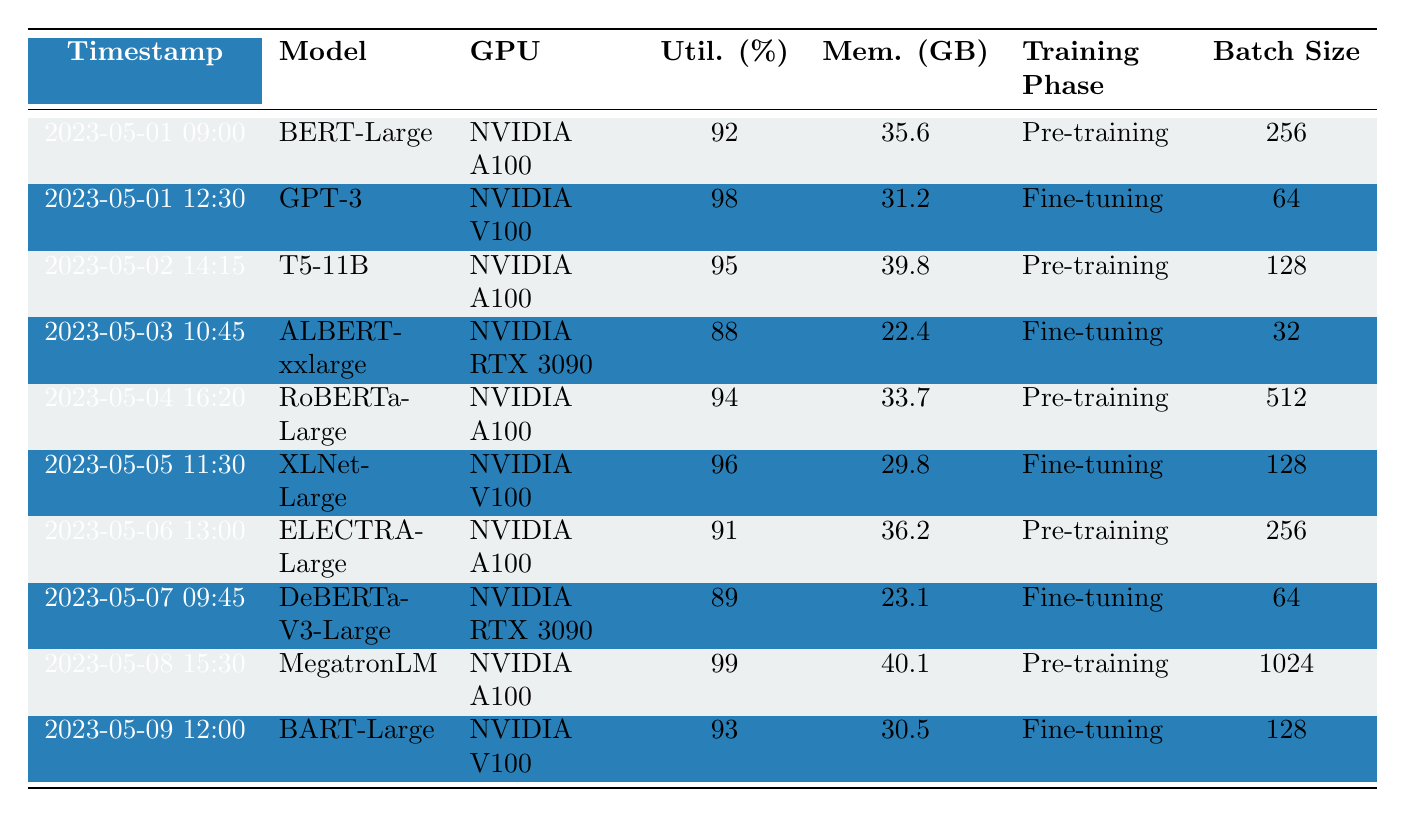What is the highest GPU utilization recorded in the table? Looking through the "Utilization (%)" column, the highest value listed is 99%, which corresponds to the "MegatronLM" model.
Answer: 99% Which GPU was used for fine-tuning the "BART-Large" model? Referring to the row for "BART-Large," the GPU listed is "NVIDIA V100."
Answer: NVIDIA V100 Calculate the average memory usage during pre-training. The memory usage for the pre-training phases are 35.6, 39.8, 33.7, 36.2, and 40.1 GB. Summing these gives 35.6 + 39.8 + 33.7 + 36.2 + 40.1 = 185.4 GB. There are 5 entries, so the average is 185.4 / 5 = 37.08 GB.
Answer: 37.08 GB Which model had the lowest GPU utilization and what was its value? The "ALBERT-xxlarge" model has the lowest GPU utilization with a value of 88%.
Answer: 88% Is there any instance of the "NVIDIA A100" GPU being used during fine-tuning in this table? Reviewing the table, there are no entries where "NVIDIA A100" is associated with a fine-tuning phase; it appears only in pre-training phases.
Answer: No Total the batch sizes for all models utilizing the "NVIDIA V100" GPU. The models utilizing "NVIDIA V100" are "GPT-3," "XLNet-Large," and "BART-Large," with batch sizes of 64, 128, and 128 respectively. Summing these gives 64 + 128 + 128 = 320.
Answer: 320 Which training phase had the highest average GPU utilization? The pre-training phase includes utilization values of 92, 95, 94, 91, and 99%. Summing these gives 471 and dividing by 5 gives an average of 94.2%. The fine-tuning phase includes 98, 88, 96, 89, and 93%, summing to 464 and averaging to 92.8%. Since 94.2% > 92.8%, pre-training has the highest average utilization.
Answer: Pre-training What is the total memory usage recorded for the "NVIDIA RTX 3090"? The memory usage for "NVIDIA RTX 3090" models "ALBERT-xxlarge" and "DeBERTa-V3-Large" is 22.4 GB and 23.1 GB, respectively. Summing these gives 22.4 + 23.1 = 45.5 GB.
Answer: 45.5 GB On which date was the "T5-11B" model utilized and what was its GPU utilization? The "T5-11B" model was utilized on "2023-05-02" with a GPU utilization of 95%.
Answer: 2023-05-02, 95% 